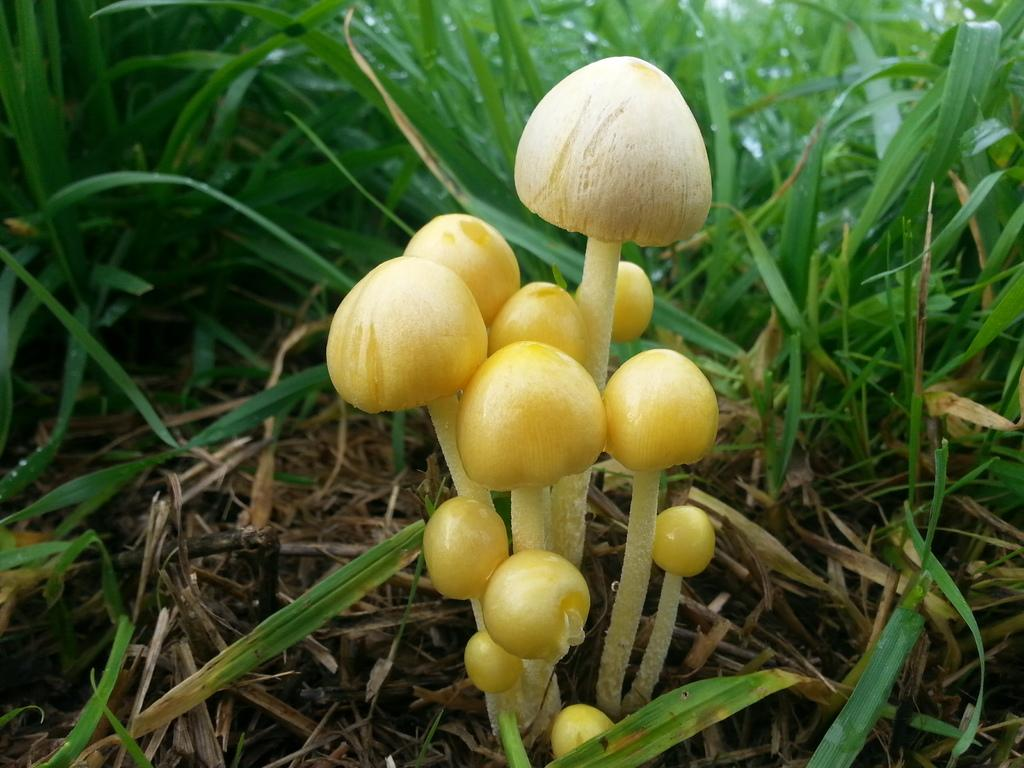What type of vegetation is present in the image? The image contains grass. What is the color of the grass in the image? The grass is green in color. What other objects can be seen in the image besides grass? There are mushrooms in the image. What is the color of the mushrooms in the image? The mushrooms are yellow in color. What type of country is depicted in the image? There is no country depicted in the image; it features grass and mushrooms. What type of tail can be seen on the mushrooms in the image? Mushrooms do not have tails, so there is no tail present in the image. 